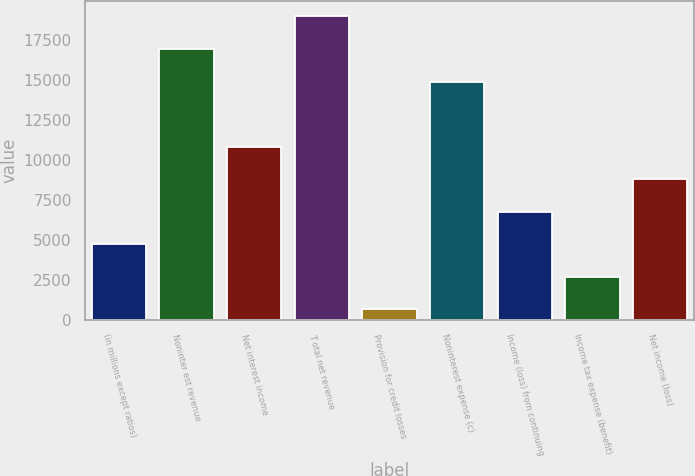Convert chart to OTSL. <chart><loc_0><loc_0><loc_500><loc_500><bar_chart><fcel>(in millions except ratios)<fcel>Noninter est revenue<fcel>Net interest income<fcel>T otal net revenue<fcel>Provision for credit losses<fcel>Noninterest expense (c)<fcel>Income (loss) from continuing<fcel>Income tax expense (benefit)<fcel>Net income (loss)<nl><fcel>4723.2<fcel>16930.8<fcel>10827<fcel>18965.4<fcel>654<fcel>14896.2<fcel>6757.8<fcel>2688.6<fcel>8792.4<nl></chart> 